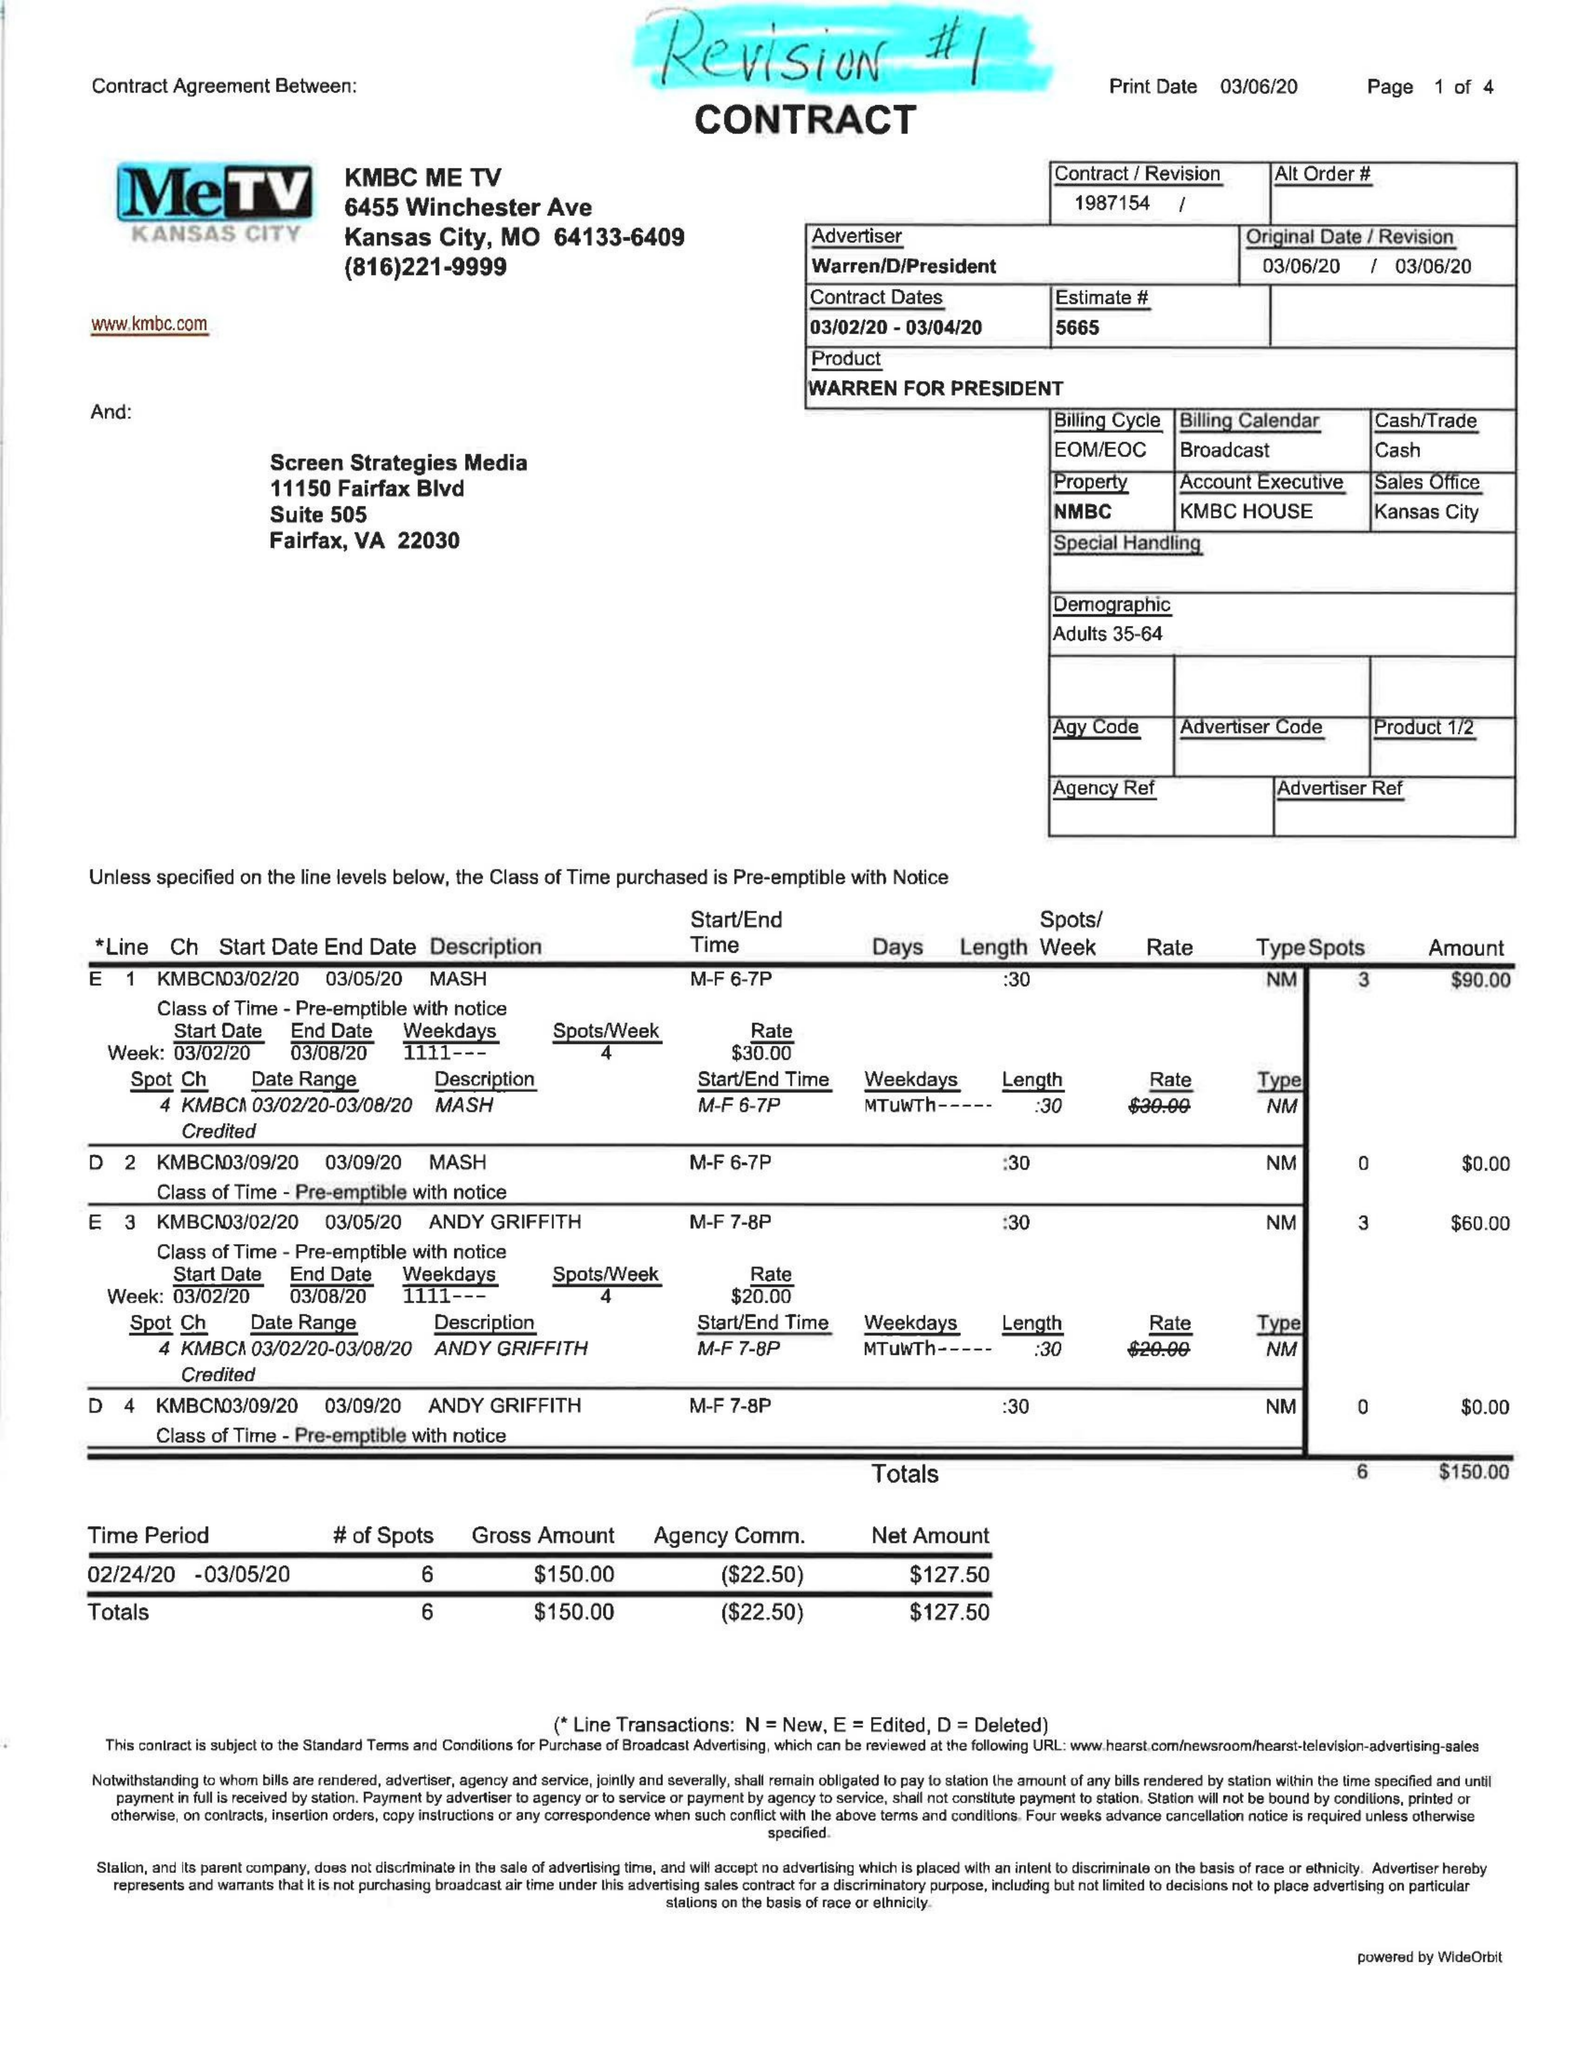What is the value for the advertiser?
Answer the question using a single word or phrase. WARREN/D/PRESIDENT 